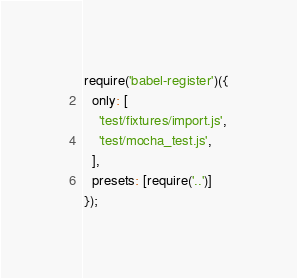Convert code to text. <code><loc_0><loc_0><loc_500><loc_500><_JavaScript_>require('babel-register')({
  only: [
    'test/fixtures/import.js',
    'test/mocha_test.js',
  ],
  presets: [require('..')]
});
</code> 